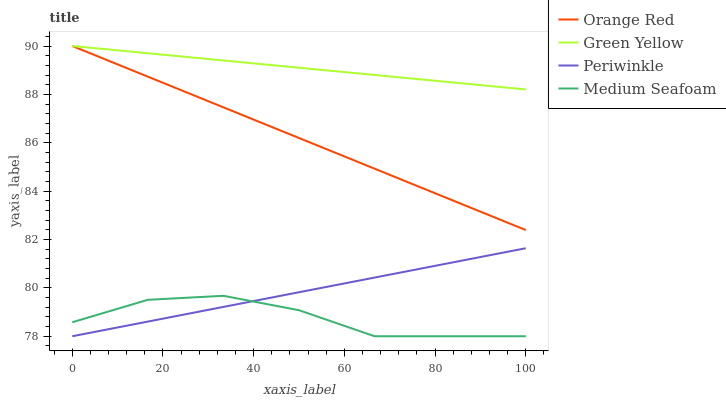Does Medium Seafoam have the minimum area under the curve?
Answer yes or no. Yes. Does Green Yellow have the maximum area under the curve?
Answer yes or no. Yes. Does Periwinkle have the minimum area under the curve?
Answer yes or no. No. Does Periwinkle have the maximum area under the curve?
Answer yes or no. No. Is Periwinkle the smoothest?
Answer yes or no. Yes. Is Medium Seafoam the roughest?
Answer yes or no. Yes. Is Orange Red the smoothest?
Answer yes or no. No. Is Orange Red the roughest?
Answer yes or no. No. Does Orange Red have the lowest value?
Answer yes or no. No. Does Periwinkle have the highest value?
Answer yes or no. No. Is Medium Seafoam less than Orange Red?
Answer yes or no. Yes. Is Green Yellow greater than Periwinkle?
Answer yes or no. Yes. Does Medium Seafoam intersect Orange Red?
Answer yes or no. No. 